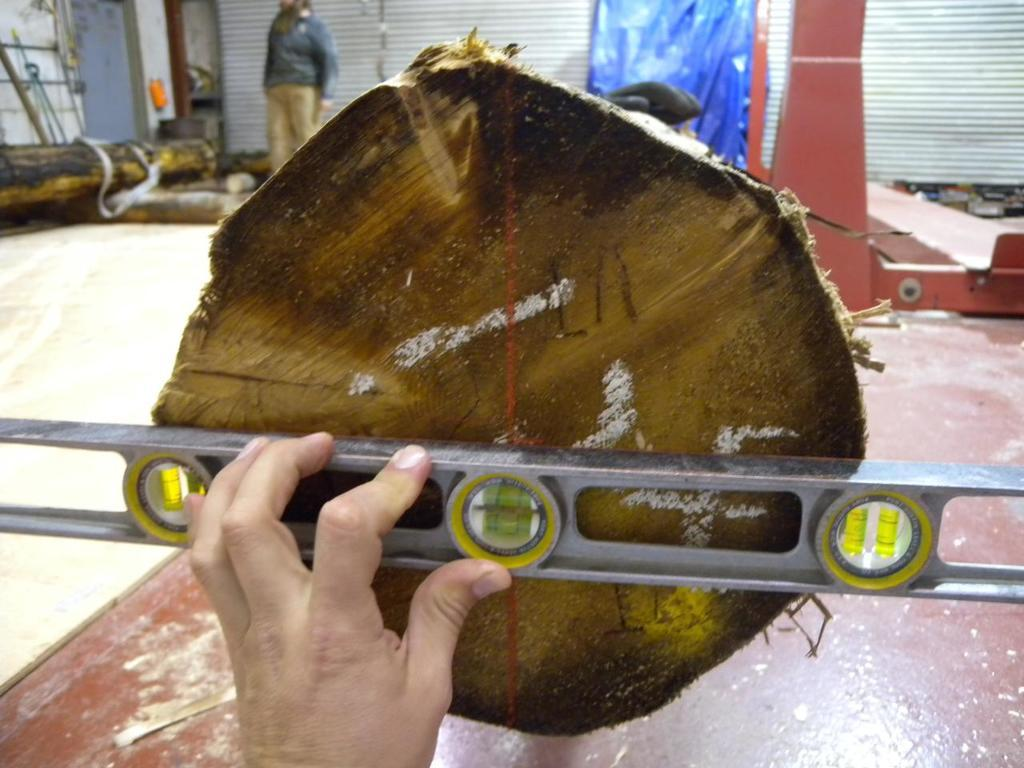What is the person in the image doing? The person is measuring a piece of wood. Where is the wood placed in the image? The wood is placed on a table. What can be seen in the background of the image? There are wooden blocks, another person, a curtain, and a wall in the background of the image. What type of whip is the person using to measure the wood in the image? There is no whip present in the image; the person is using a measuring tool, likely a ruler or tape measure. 